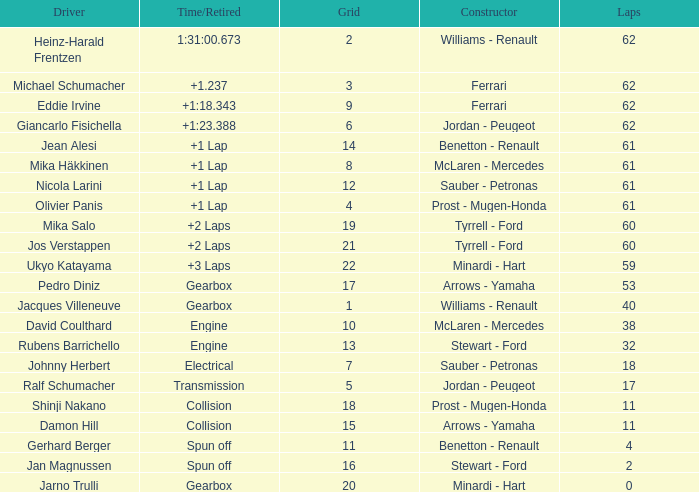What is the time/retired with 60 laps and a grid 19? +2 Laps. 